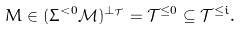<formula> <loc_0><loc_0><loc_500><loc_500>M \in ( \Sigma ^ { < 0 } \mathcal { M } ) ^ { \perp _ { \mathcal { T } } } = \mathcal { T } ^ { \leq 0 } \subseteq \mathcal { T } ^ { \leq i } .</formula> 